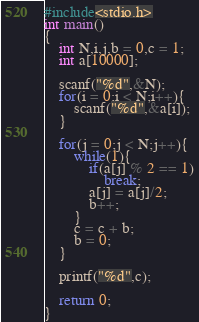<code> <loc_0><loc_0><loc_500><loc_500><_C_>#include<stdio.h>
int main()
{
    int N,i,j,b = 0,c = 1;
    int a[10000];

    scanf("%d",&N);
    for(i = 0;i < N;i++){
    	scanf("%d",&a[i]);
    }

    for(j = 0;j < N;j++){
    	while(1){
    		if(a[j] % 2 == 1)
    			break;
    		a[j] = a[j]/2;
    		b++;
    	}
    	c = c + b;
    	b = 0;
    }

    printf("%d",c);

    return 0;
}</code> 